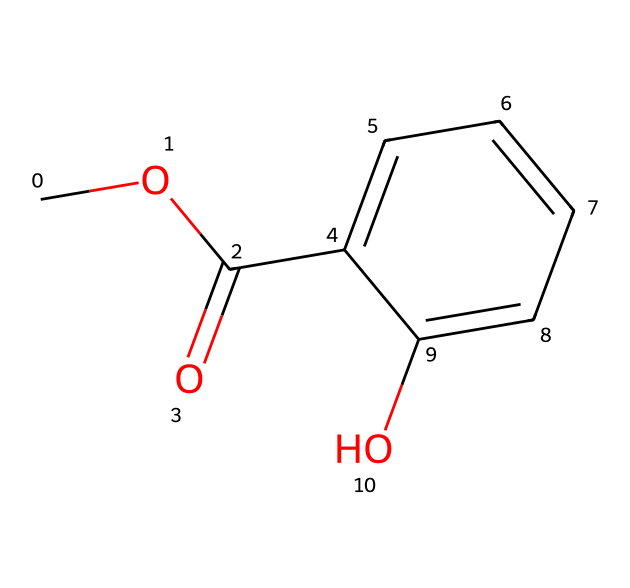What is the molecular formula of methyl salicylate? By analyzing the structure from the SMILES representation, we can count the number of each type of atom present. The representation shows one carbon atom in the methoxy group (OCH3), six in the aromatic ring, one in the carbonyl part (C=O), and one in the ethyl part (C), with three oxygens in total. Counting these gives us the molecular formula C9H10O3.
Answer: C9H10O3 How many carbon atoms are in methyl salicylate? From the structure, we can count the carbon atoms directly. The SMILES indicates a total of nine carbon atoms present in various functional groups and the aromatic ring.
Answer: 9 What functional groups are present in methyl salicylate? By examining the structure, we identify two primary functional groups: an ester group (-COO-) indicated by the carbonyl (C=O) and the oxygen (O) connected to the methoxy group and a hydroxy group (-OH) represented by the hydroxyl on the aromatic ring.
Answer: ester and hydroxyl What type of ester is methyl salicylate? This compound is a type of aromatic ester due to the presence of an aromatic ring that is part of its structure, which is typical of compounds derived from salicylic acid.
Answer: aromatic ester What is the significance of the hydroxy group in methyl salicylate? The hydroxy group (-OH) contributes to the solubility of the compound in water and can also participate in hydrogen bonding, enhancing its interactions in biological systems. This influences its usage in traditional medicine as a soothing agent.
Answer: solubility and medicinal properties Which part of the structure indicates the presence of an aromatic system? The presence of a continuous cycle of conjugated double bonds within a six-membered carbon ring indicates the presence of the aromatic system, which can be observed in the structure containing the five carbon atoms arranged with alternating single and double bonds.
Answer: aromatic ring 